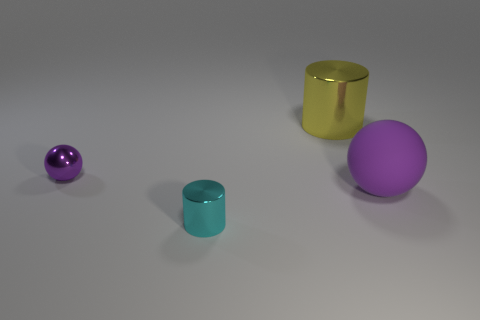Add 4 brown cylinders. How many objects exist? 8 Add 1 purple metal things. How many purple metal things exist? 2 Subtract 0 purple cubes. How many objects are left? 4 Subtract all small purple metallic spheres. Subtract all tiny objects. How many objects are left? 1 Add 3 large yellow cylinders. How many large yellow cylinders are left? 4 